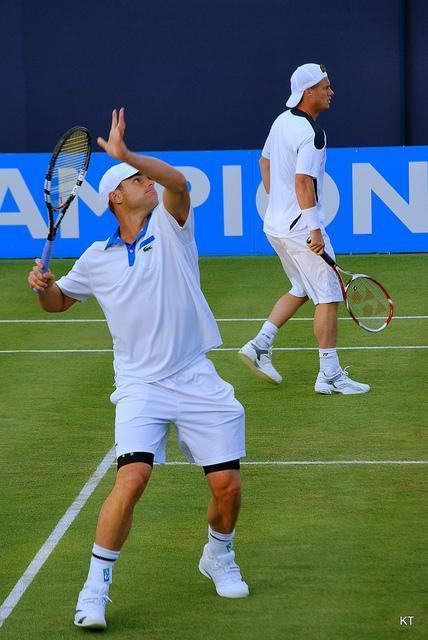How many people are there?
Give a very brief answer. 2. How many tennis rackets are there?
Give a very brief answer. 2. How many zebras are in the picture?
Give a very brief answer. 0. 